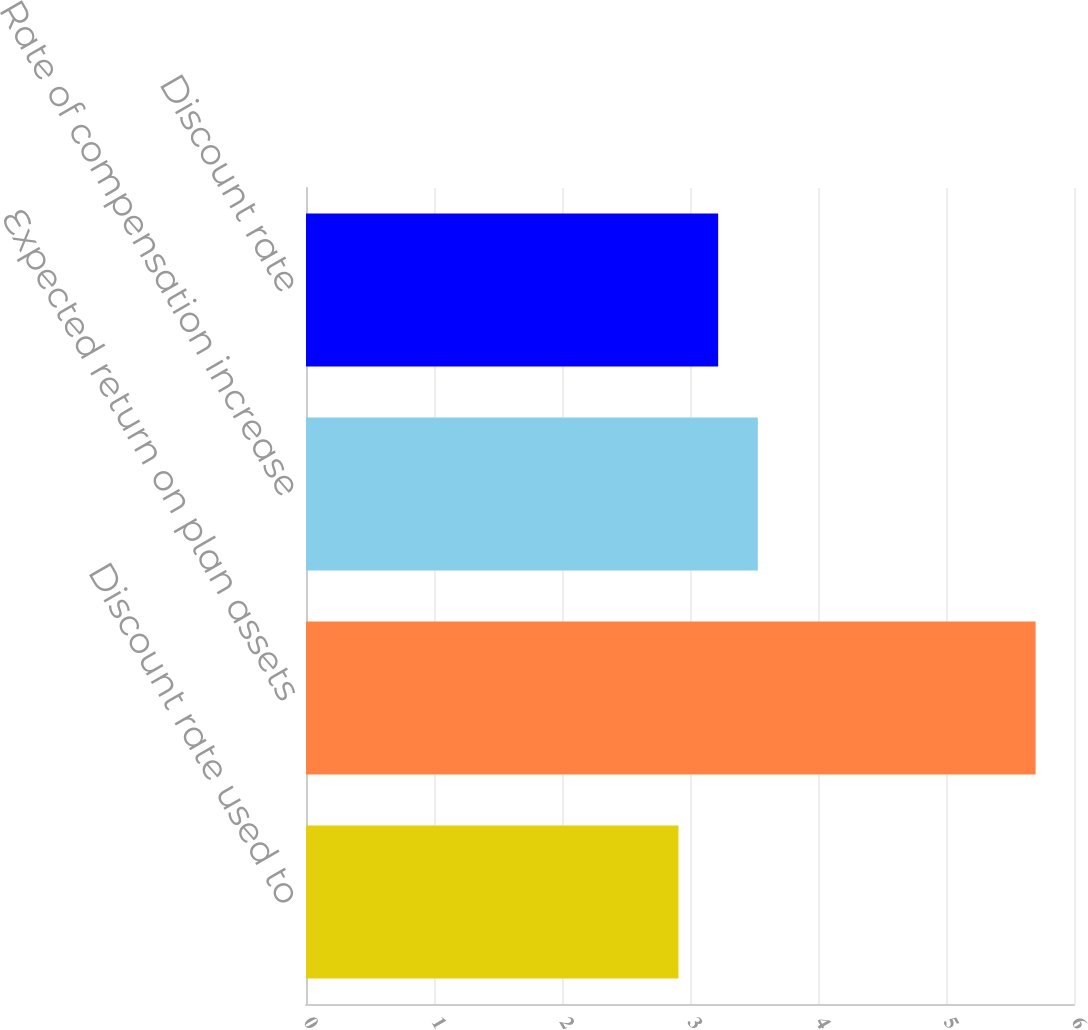Convert chart. <chart><loc_0><loc_0><loc_500><loc_500><bar_chart><fcel>Discount rate used to<fcel>Expected return on plan assets<fcel>Rate of compensation increase<fcel>Discount rate<nl><fcel>2.91<fcel>5.7<fcel>3.53<fcel>3.22<nl></chart> 